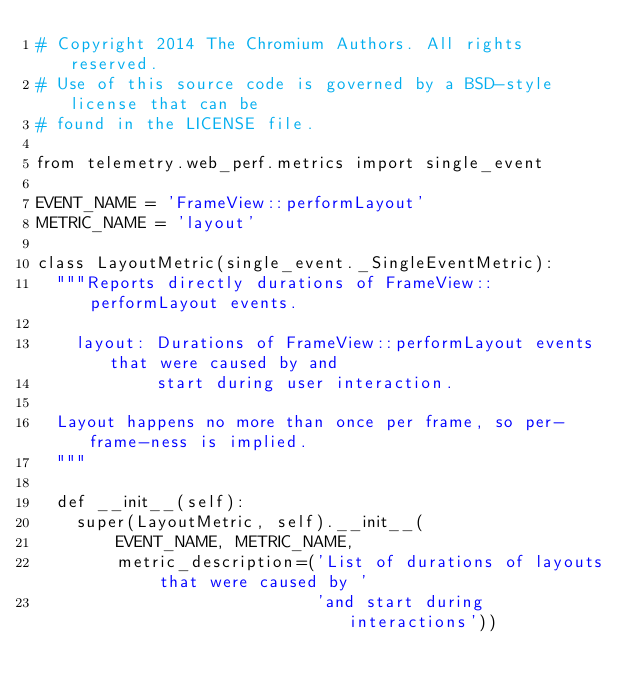Convert code to text. <code><loc_0><loc_0><loc_500><loc_500><_Python_># Copyright 2014 The Chromium Authors. All rights reserved.
# Use of this source code is governed by a BSD-style license that can be
# found in the LICENSE file.

from telemetry.web_perf.metrics import single_event

EVENT_NAME = 'FrameView::performLayout'
METRIC_NAME = 'layout'

class LayoutMetric(single_event._SingleEventMetric):
  """Reports directly durations of FrameView::performLayout events.

    layout: Durations of FrameView::performLayout events that were caused by and
            start during user interaction.

  Layout happens no more than once per frame, so per-frame-ness is implied.
  """

  def __init__(self):
    super(LayoutMetric, self).__init__(
        EVENT_NAME, METRIC_NAME,
        metric_description=('List of durations of layouts that were caused by '
                            'and start during interactions'))
</code> 